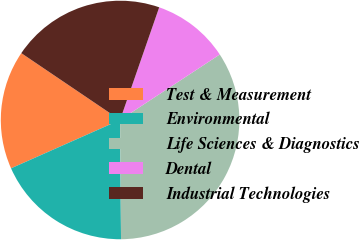Convert chart to OTSL. <chart><loc_0><loc_0><loc_500><loc_500><pie_chart><fcel>Test & Measurement<fcel>Environmental<fcel>Life Sciences & Diagnostics<fcel>Dental<fcel>Industrial Technologies<nl><fcel>16.11%<fcel>18.48%<fcel>34.12%<fcel>10.43%<fcel>20.85%<nl></chart> 